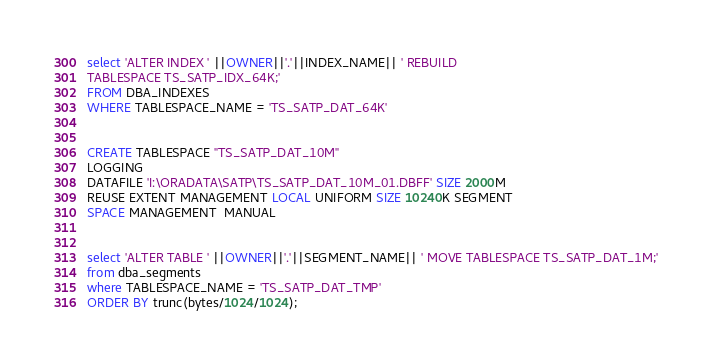Convert code to text. <code><loc_0><loc_0><loc_500><loc_500><_SQL_>

select 'ALTER INDEX ' ||OWNER||'.'||INDEX_NAME|| ' REBUILD
TABLESPACE TS_SATP_IDX_64K;'
FROM DBA_INDEXES
WHERE TABLESPACE_NAME = 'TS_SATP_DAT_64K'


CREATE TABLESPACE "TS_SATP_DAT_10M" 
LOGGING 
DATAFILE 'I:\ORADATA\SATP\TS_SATP_DAT_10M_01.DBFF' SIZE 2000M 
REUSE EXTENT MANAGEMENT LOCAL UNIFORM SIZE 10240K SEGMENT 
SPACE MANAGEMENT  MANUAL 


select 'ALTER TABLE ' ||OWNER||'.'||SEGMENT_NAME|| ' MOVE TABLESPACE TS_SATP_DAT_1M;'
from dba_segments
where TABLESPACE_NAME = 'TS_SATP_DAT_TMP'
ORDER BY trunc(bytes/1024/1024);

</code> 